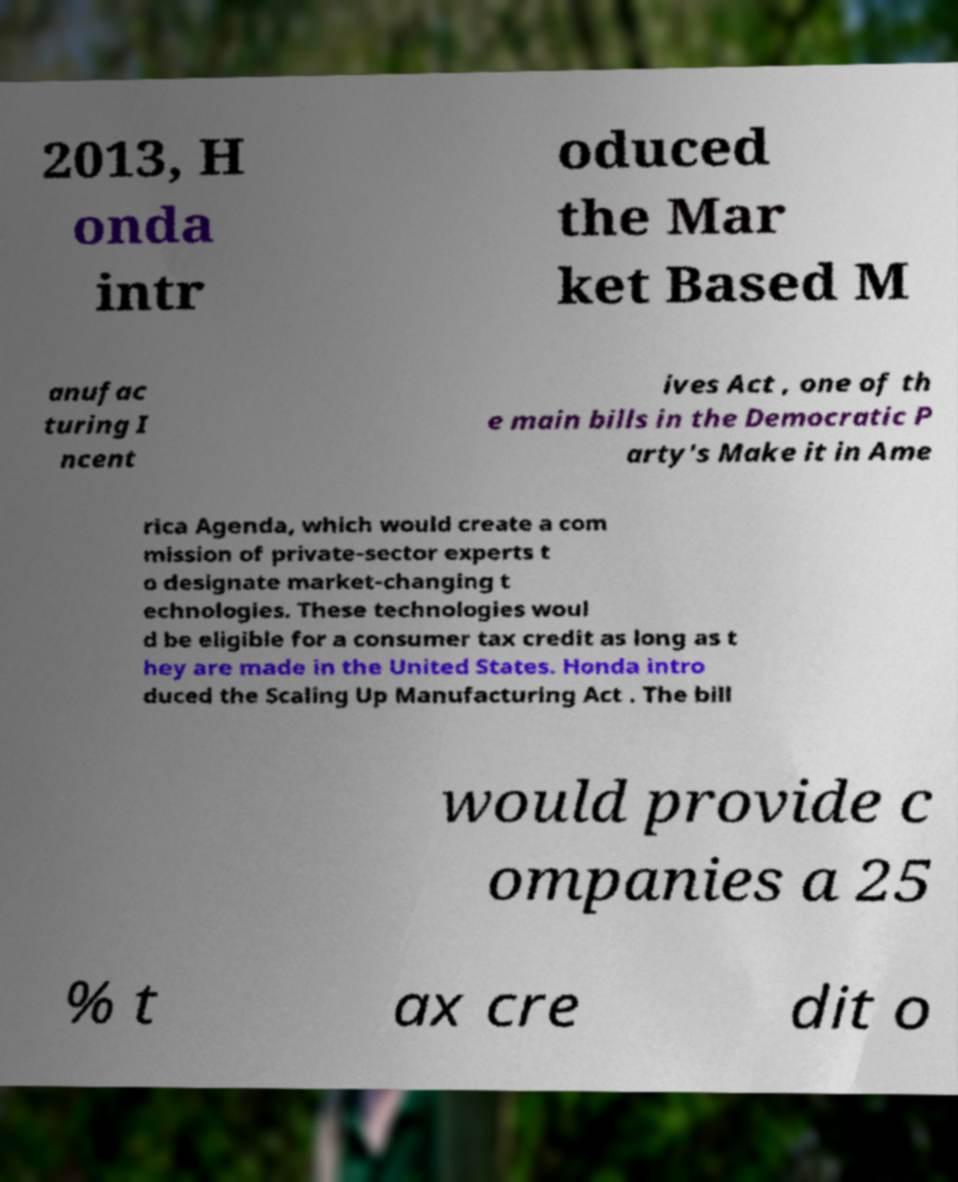For documentation purposes, I need the text within this image transcribed. Could you provide that? 2013, H onda intr oduced the Mar ket Based M anufac turing I ncent ives Act , one of th e main bills in the Democratic P arty's Make it in Ame rica Agenda, which would create a com mission of private-sector experts t o designate market-changing t echnologies. These technologies woul d be eligible for a consumer tax credit as long as t hey are made in the United States. Honda intro duced the Scaling Up Manufacturing Act . The bill would provide c ompanies a 25 % t ax cre dit o 